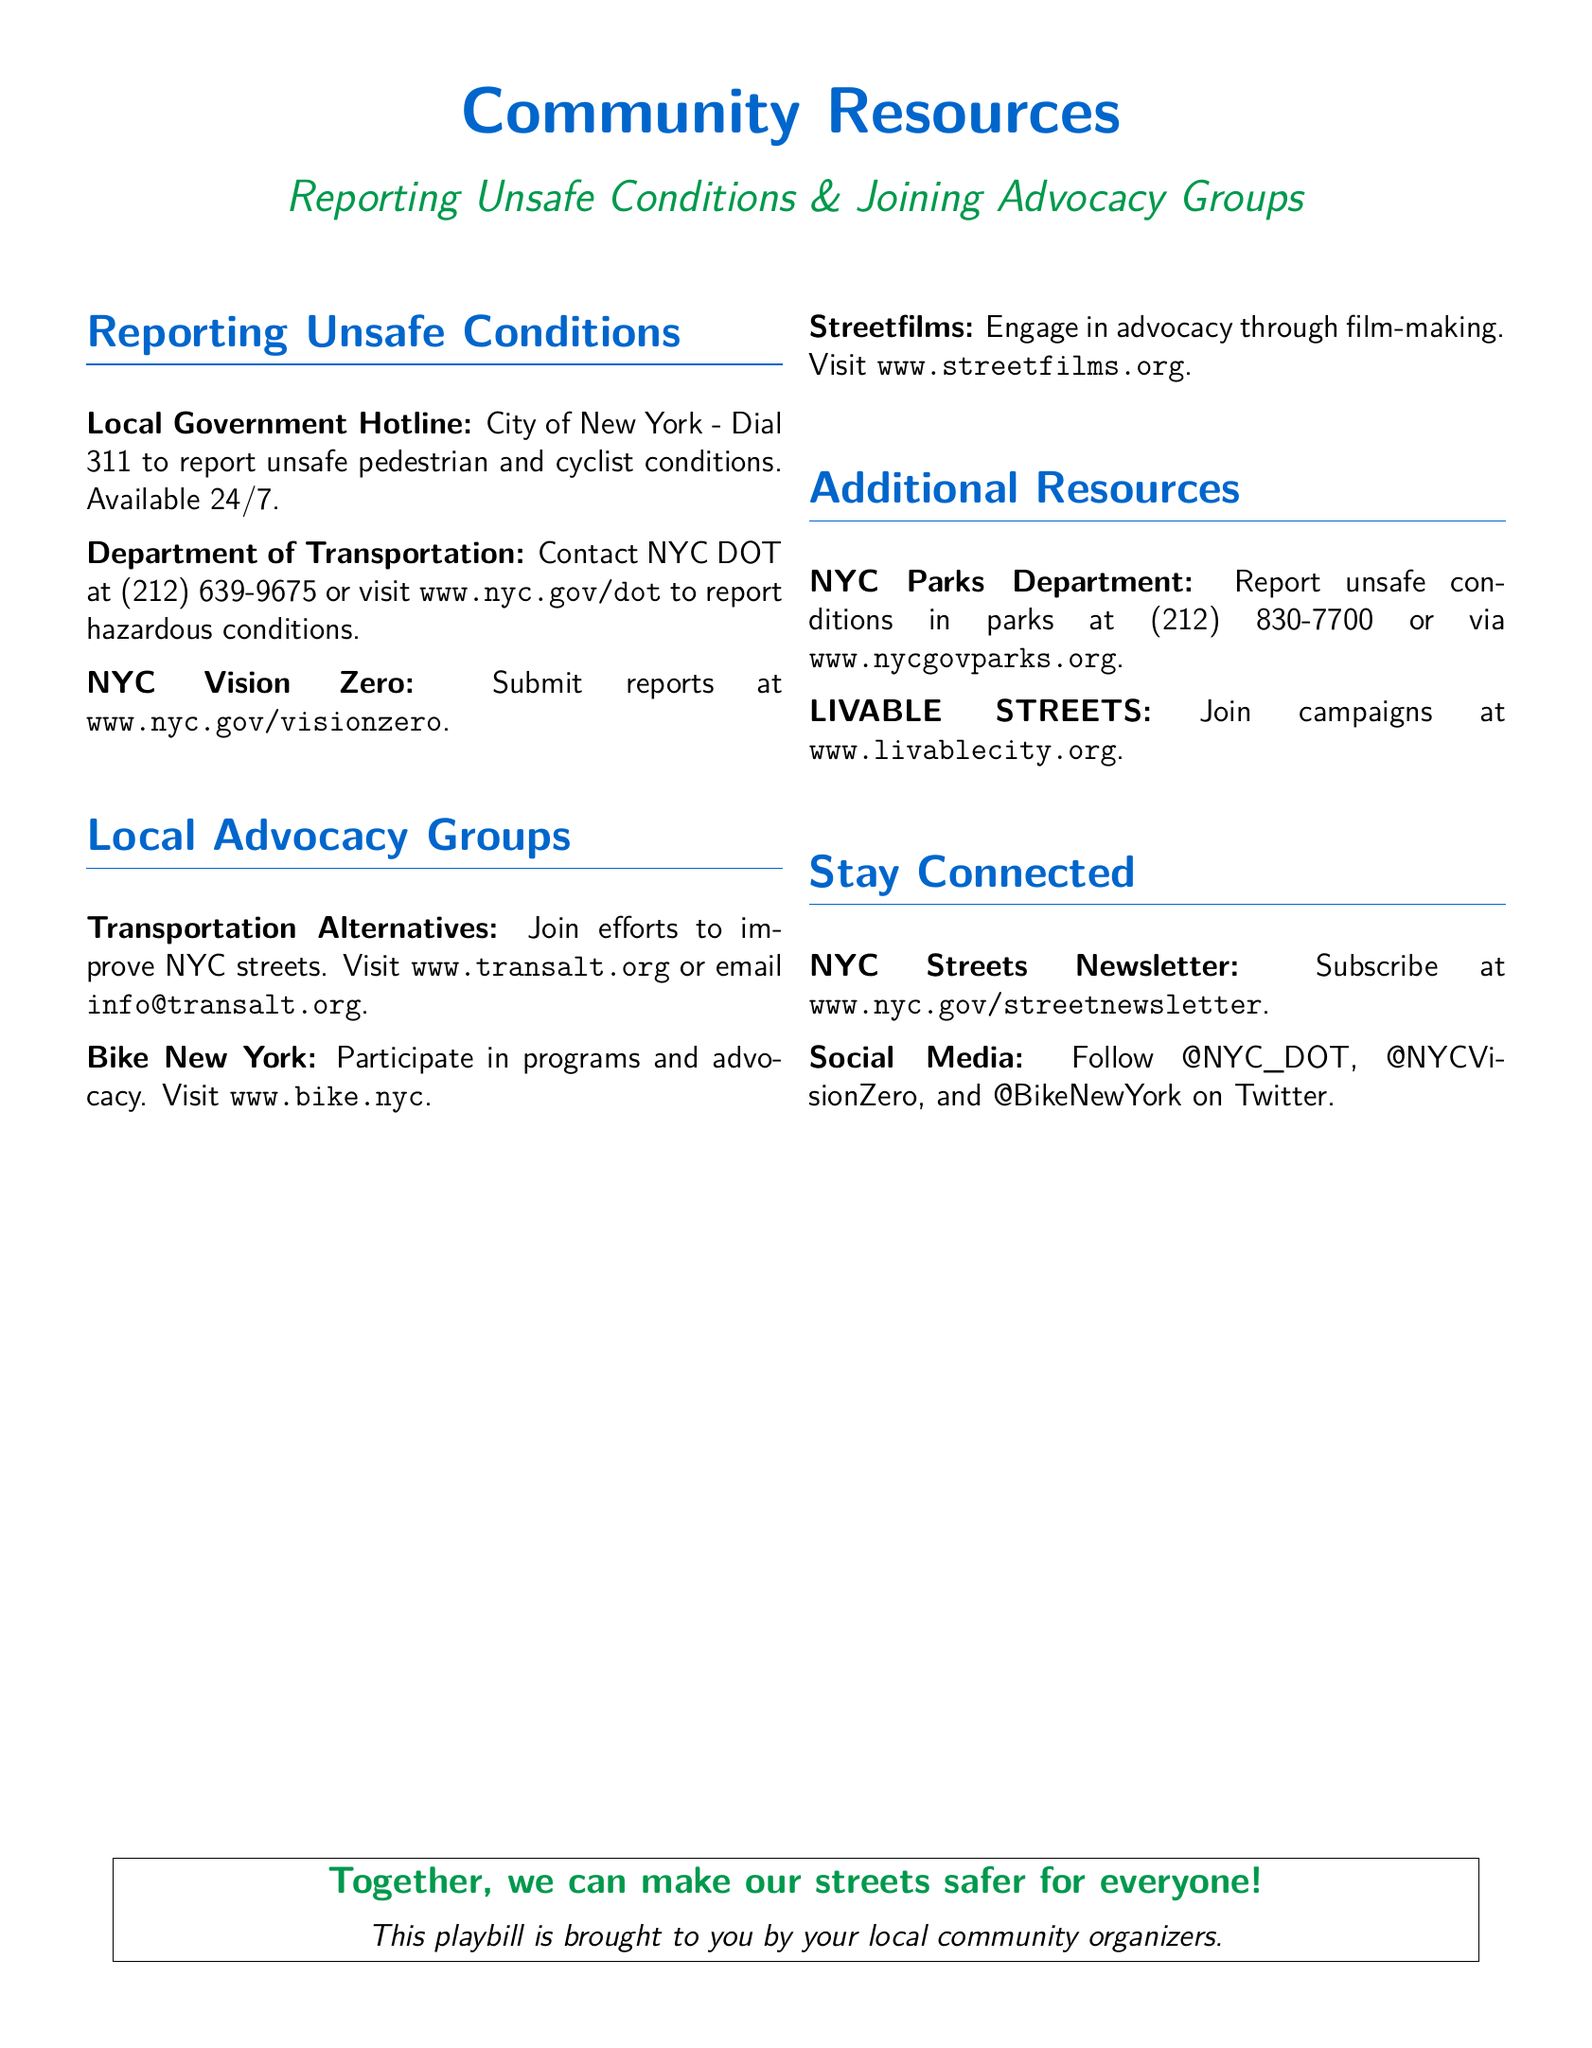What is the local government hotline number? The document specifies the City of New York hotline number for reporting unsafe conditions as 311.
Answer: 311 What is the website for NYC Vision Zero? The website for reporting through NYC Vision Zero can be found at www.nyc.gov/visionzero.
Answer: www.nyc.gov/visionzero Which advocacy group focuses on improving NYC streets? The document states that Transportation Alternatives is the advocacy group focused on improving NYC streets.
Answer: Transportation Alternatives What is the contact number for the NYC Parks Department? The document mentions the contact number for the NYC Parks Department is (212) 830-7700.
Answer: (212) 830-7700 How can you subscribe to the NYC Streets Newsletter? The document indicates you can subscribe to the NYC Streets Newsletter at www.nyc.gov/streetnewsletter.
Answer: www.nyc.gov/streetnewsletter What is Streetfilms' main activity? The document states that Streetfilms engages in advocacy through film-making.
Answer: Film-making What is the email address for Transportation Alternatives? The document lists the email address for Transportation Alternatives as info@transalt.org.
Answer: info@transalt.org What is the common goal stated in the Playbill? The document's concluding statement emphasizes making streets safer for everyone as the common goal.
Answer: Safer streets for everyone 